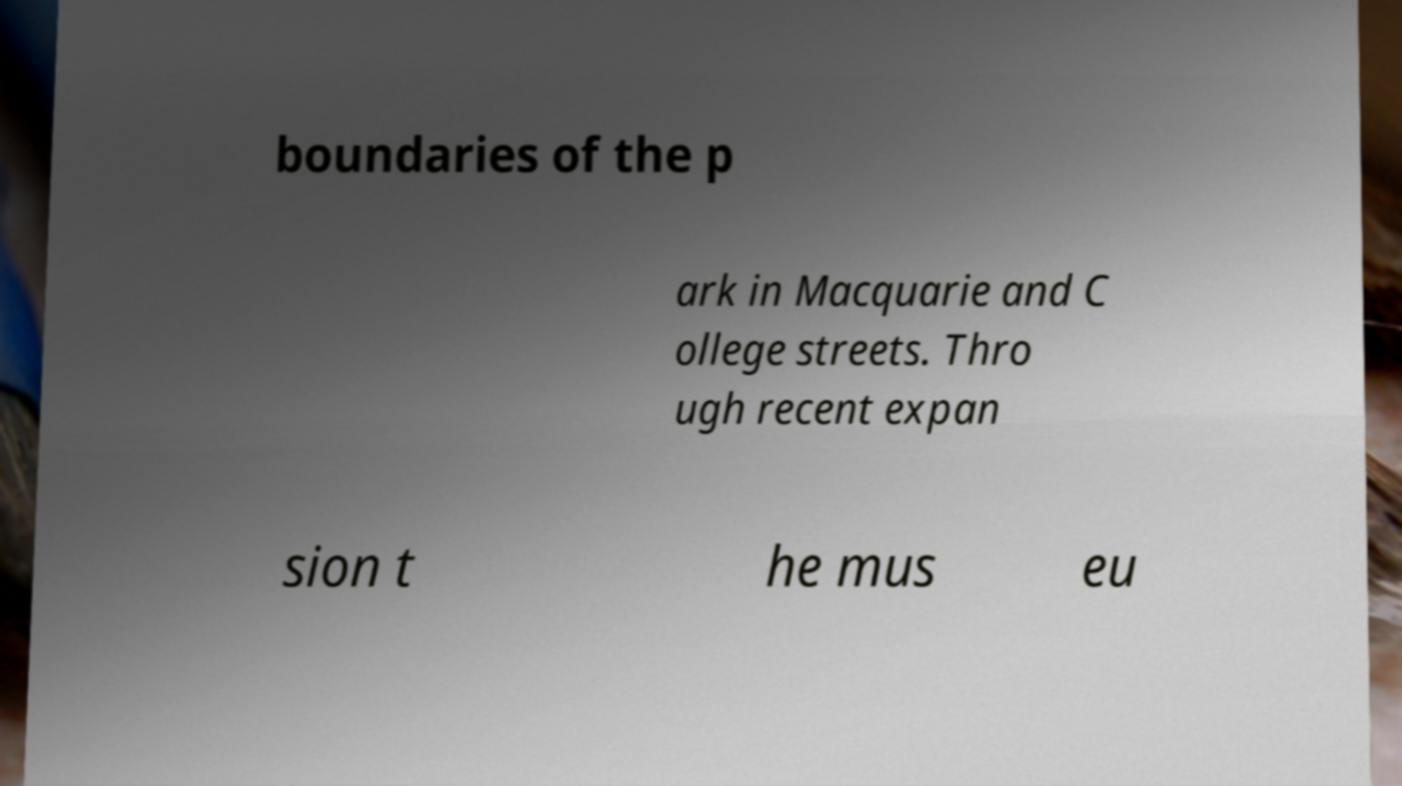Please read and relay the text visible in this image. What does it say? boundaries of the p ark in Macquarie and C ollege streets. Thro ugh recent expan sion t he mus eu 